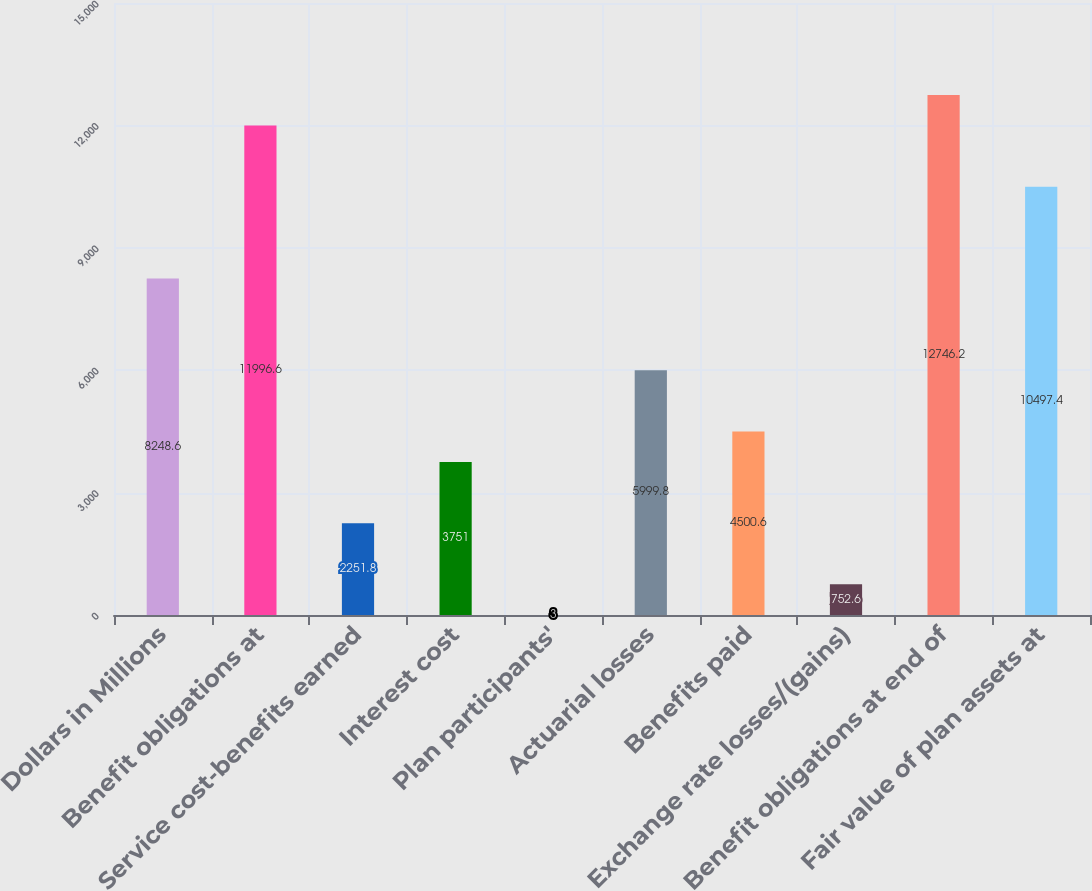Convert chart to OTSL. <chart><loc_0><loc_0><loc_500><loc_500><bar_chart><fcel>Dollars in Millions<fcel>Benefit obligations at<fcel>Service cost-benefits earned<fcel>Interest cost<fcel>Plan participants'<fcel>Actuarial losses<fcel>Benefits paid<fcel>Exchange rate losses/(gains)<fcel>Benefit obligations at end of<fcel>Fair value of plan assets at<nl><fcel>8248.6<fcel>11996.6<fcel>2251.8<fcel>3751<fcel>3<fcel>5999.8<fcel>4500.6<fcel>752.6<fcel>12746.2<fcel>10497.4<nl></chart> 